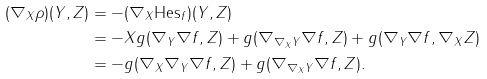<formula> <loc_0><loc_0><loc_500><loc_500>( \nabla _ { X } \rho ) ( Y , Z ) & = - ( \nabla _ { X } \text {Hes} _ { f } ) ( Y , Z ) \\ & = - X g ( \nabla _ { Y } \nabla f , Z ) + g ( \nabla _ { \nabla _ { X } Y } \nabla f , Z ) + g ( \nabla _ { Y } \nabla f , \nabla _ { X } Z ) \\ & = - g ( \nabla _ { X } \nabla _ { Y } \nabla f , Z ) + g ( \nabla _ { \nabla _ { X } Y } \nabla f , Z ) .</formula> 